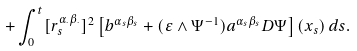Convert formula to latex. <formula><loc_0><loc_0><loc_500><loc_500>+ \int _ { 0 } ^ { t } [ r ^ { \alpha _ { \cdot } \beta _ { \cdot } } _ { s } ] ^ { 2 } \left [ b ^ { \alpha _ { s } \beta _ { s } } + ( \varepsilon \wedge \Psi ^ { - 1 } ) a ^ { \alpha _ { s } \beta _ { s } } D \Psi \right ] ( x _ { s } ) \, d s .</formula> 